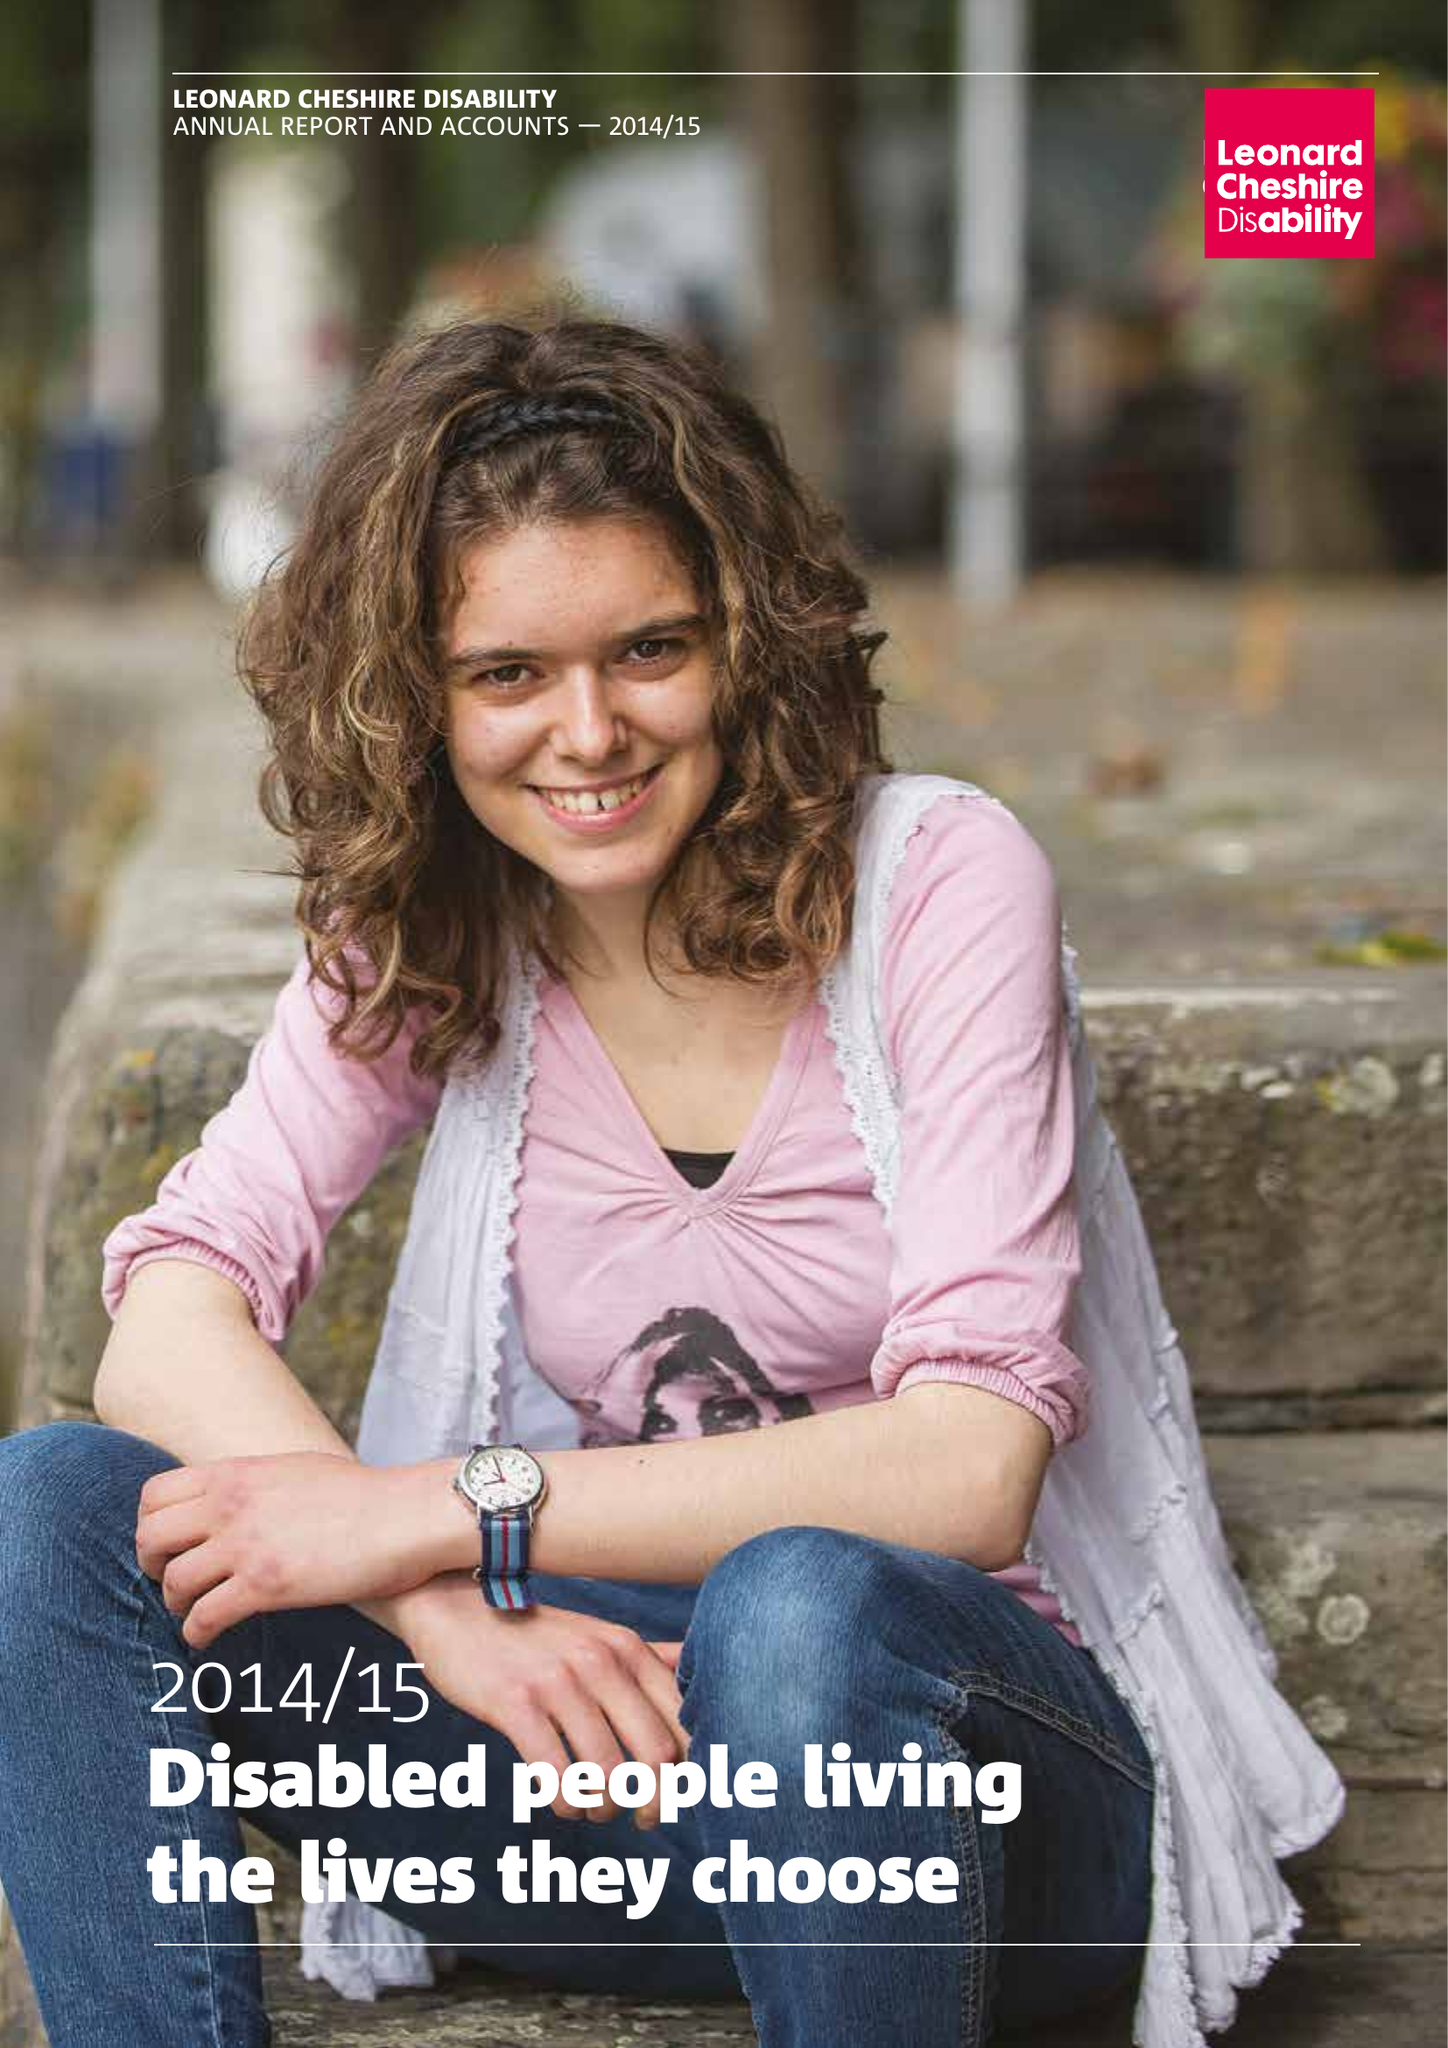What is the value for the charity_number?
Answer the question using a single word or phrase. 218186 